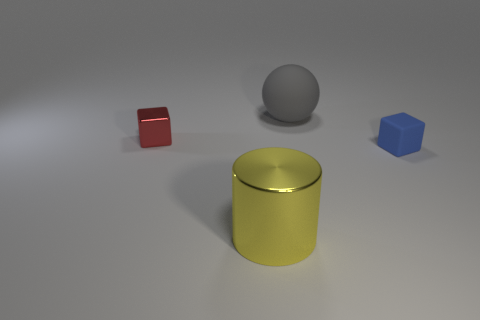Add 1 large shiny spheres. How many objects exist? 5 Add 3 spheres. How many spheres are left? 4 Add 3 red metallic blocks. How many red metallic blocks exist? 4 Subtract 0 blue cylinders. How many objects are left? 4 Subtract all large red shiny objects. Subtract all small matte things. How many objects are left? 3 